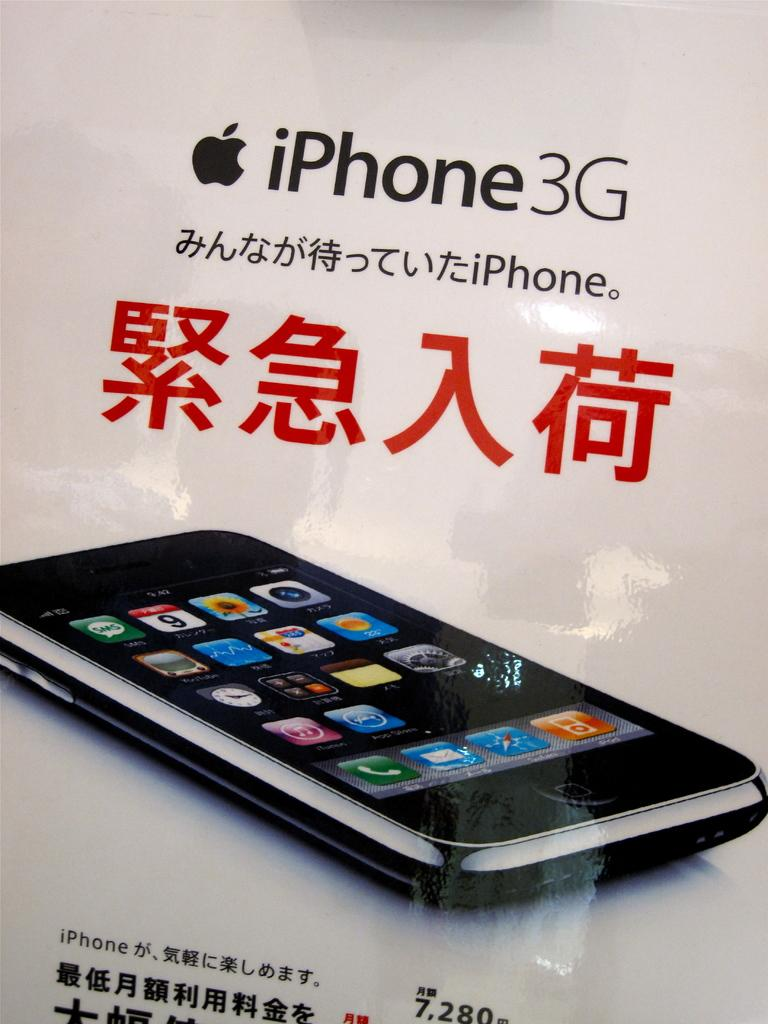<image>
Relay a brief, clear account of the picture shown. The poster shown is of the iPhone3G with foreign writing accompanying it. 